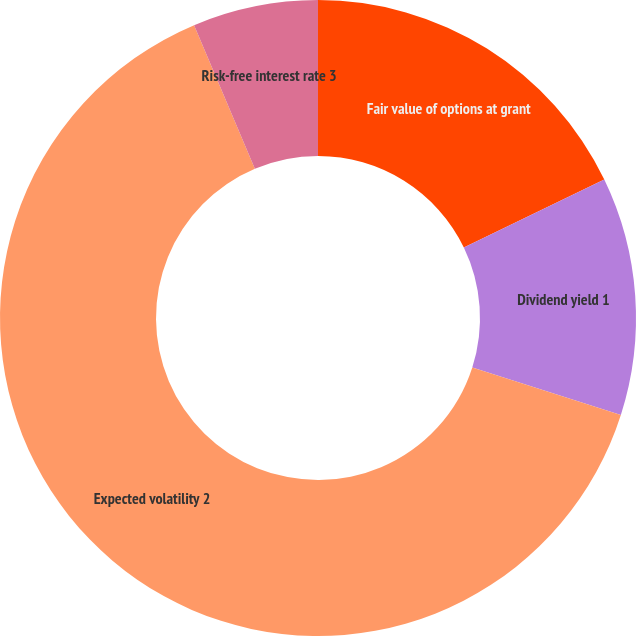<chart> <loc_0><loc_0><loc_500><loc_500><pie_chart><fcel>Fair value of options at grant<fcel>Dividend yield 1<fcel>Expected volatility 2<fcel>Risk-free interest rate 3<nl><fcel>17.83%<fcel>12.1%<fcel>63.69%<fcel>6.37%<nl></chart> 